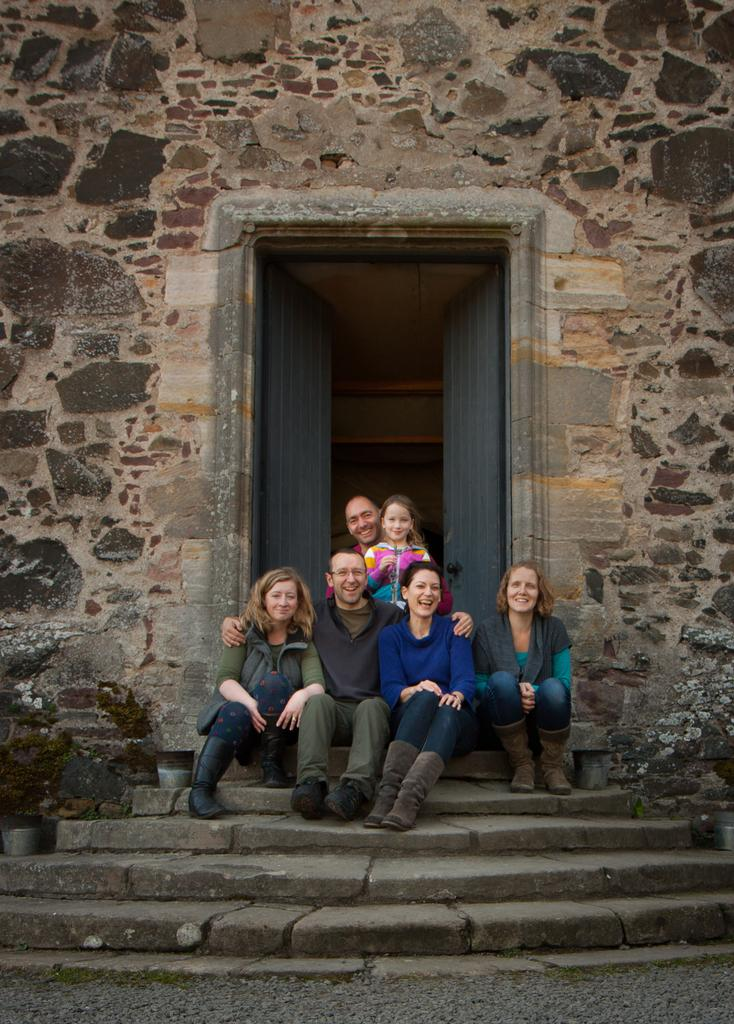What are the people in the image doing? The people in the image are sitting. What architectural feature can be seen in the image? There are stairs in the image. What type of entrance is visible in the image? There are doors in the image. What structural element is present in the image? There is a wall in the image. What type of vegetable is being used as a seat by the people in the image? There is no vegetable present in the image; the people are sitting on chairs or a similar seating arrangement. How does the zebra drop into the image? There is no zebra present in the image, so it cannot drop into the image. 